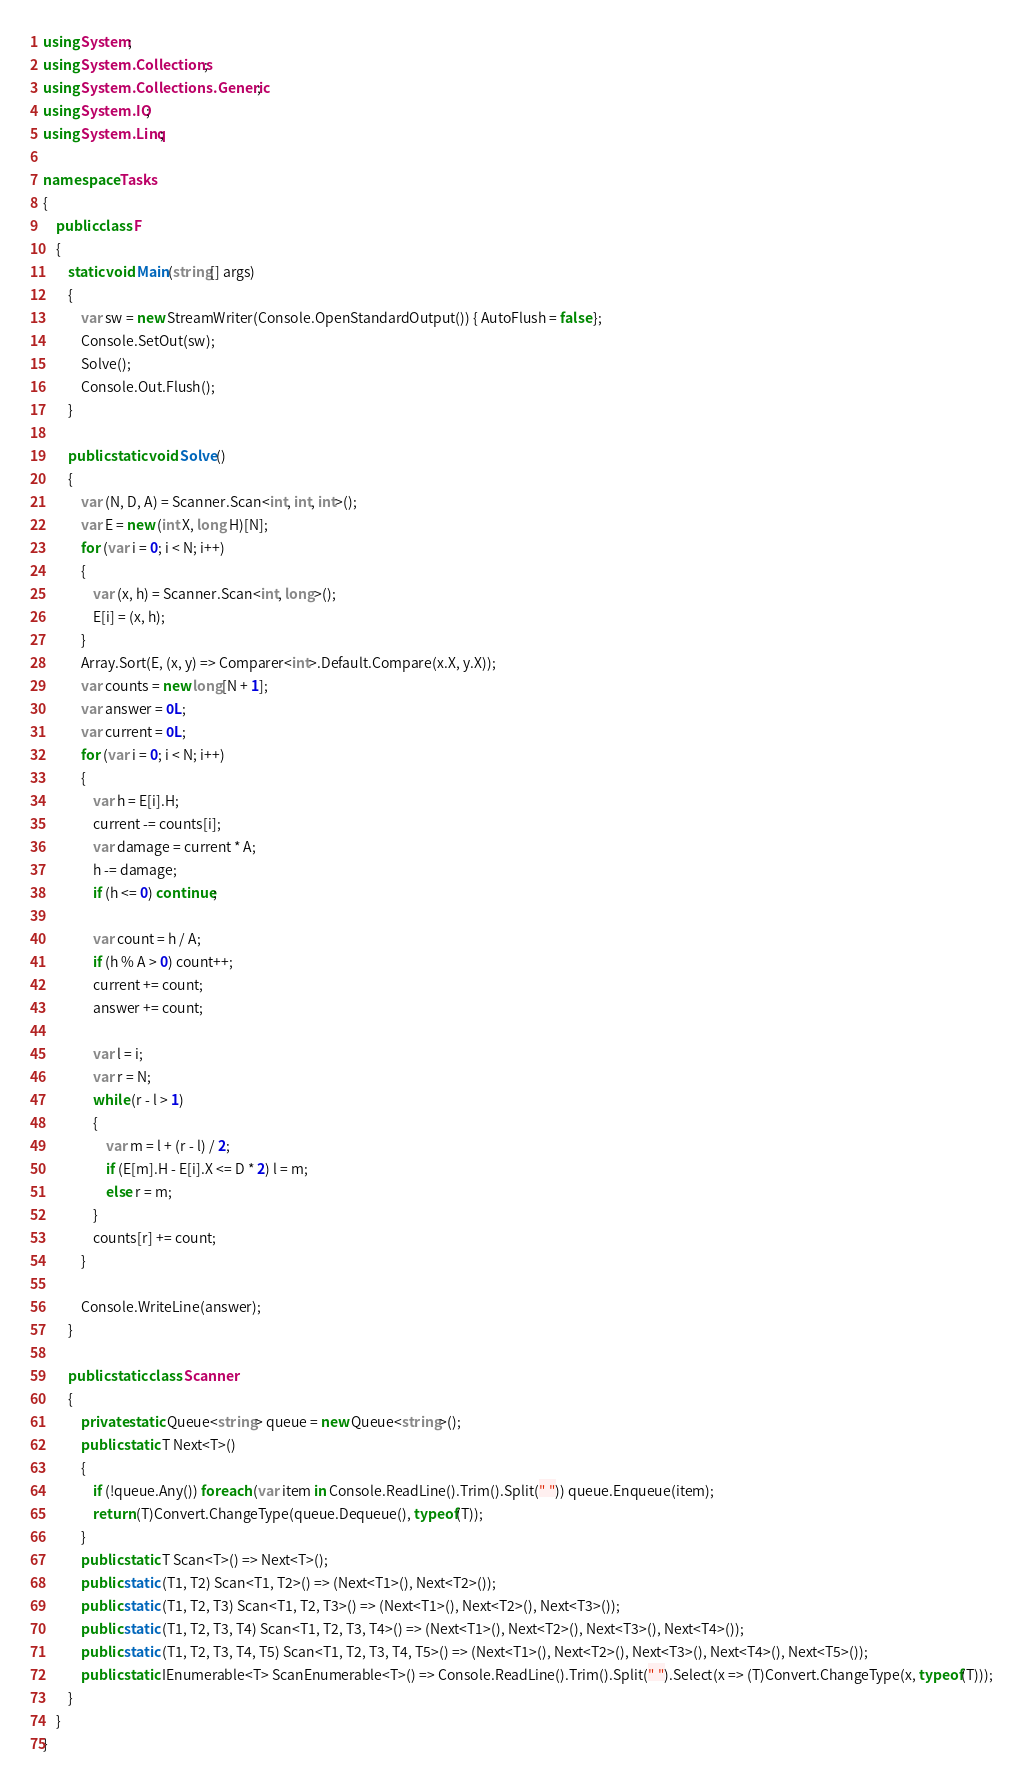<code> <loc_0><loc_0><loc_500><loc_500><_C#_>using System;
using System.Collections;
using System.Collections.Generic;
using System.IO;
using System.Linq;

namespace Tasks
{
    public class F
    {
        static void Main(string[] args)
        {
            var sw = new StreamWriter(Console.OpenStandardOutput()) { AutoFlush = false };
            Console.SetOut(sw);
            Solve();
            Console.Out.Flush();
        }

        public static void Solve()
        {
            var (N, D, A) = Scanner.Scan<int, int, int>();
            var E = new (int X, long H)[N];
            for (var i = 0; i < N; i++)
            {
                var (x, h) = Scanner.Scan<int, long>();
                E[i] = (x, h);
            }
            Array.Sort(E, (x, y) => Comparer<int>.Default.Compare(x.X, y.X));
            var counts = new long[N + 1];
            var answer = 0L;
            var current = 0L;
            for (var i = 0; i < N; i++)
            {
                var h = E[i].H;
                current -= counts[i];
                var damage = current * A;
                h -= damage;
                if (h <= 0) continue;

                var count = h / A;
                if (h % A > 0) count++;
                current += count;
                answer += count;

                var l = i;
                var r = N;
                while (r - l > 1)
                {
                    var m = l + (r - l) / 2;
                    if (E[m].H - E[i].X <= D * 2) l = m;
                    else r = m;
                }
                counts[r] += count;
            }

            Console.WriteLine(answer);
        }

        public static class Scanner
        {
            private static Queue<string> queue = new Queue<string>();
            public static T Next<T>()
            {
                if (!queue.Any()) foreach (var item in Console.ReadLine().Trim().Split(" ")) queue.Enqueue(item);
                return (T)Convert.ChangeType(queue.Dequeue(), typeof(T));
            }
            public static T Scan<T>() => Next<T>();
            public static (T1, T2) Scan<T1, T2>() => (Next<T1>(), Next<T2>());
            public static (T1, T2, T3) Scan<T1, T2, T3>() => (Next<T1>(), Next<T2>(), Next<T3>());
            public static (T1, T2, T3, T4) Scan<T1, T2, T3, T4>() => (Next<T1>(), Next<T2>(), Next<T3>(), Next<T4>());
            public static (T1, T2, T3, T4, T5) Scan<T1, T2, T3, T4, T5>() => (Next<T1>(), Next<T2>(), Next<T3>(), Next<T4>(), Next<T5>());
            public static IEnumerable<T> ScanEnumerable<T>() => Console.ReadLine().Trim().Split(" ").Select(x => (T)Convert.ChangeType(x, typeof(T)));
        }
    }
}
</code> 